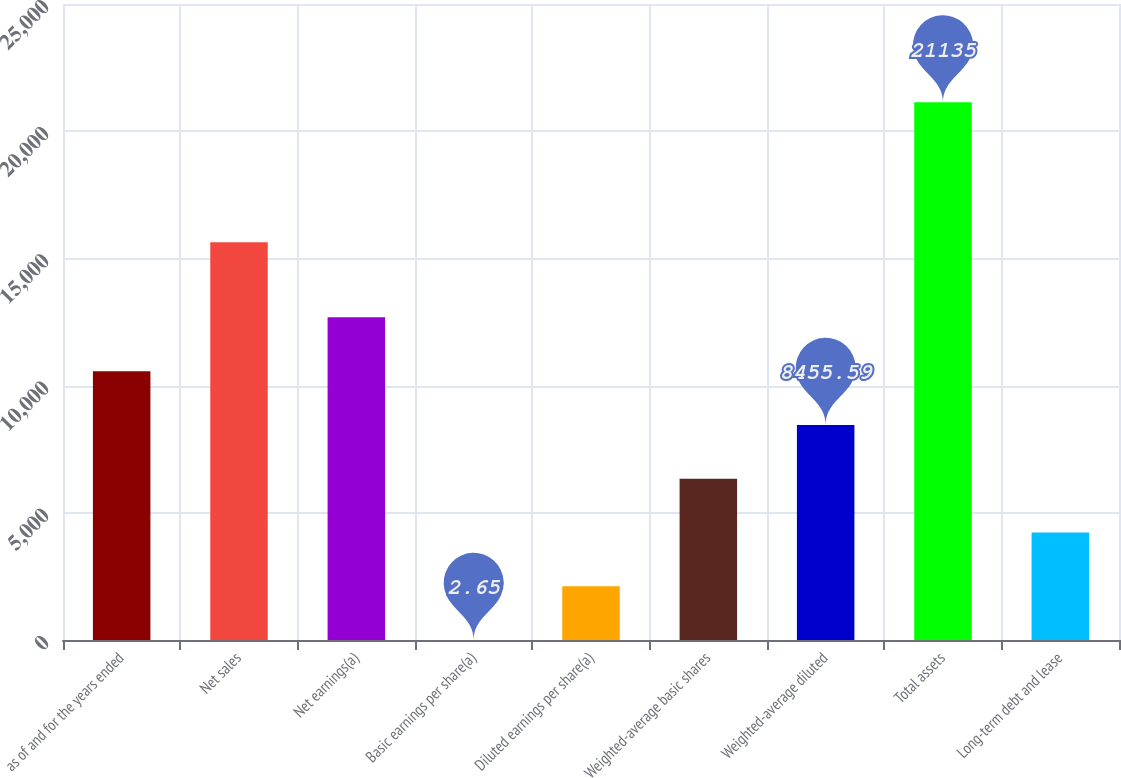Convert chart. <chart><loc_0><loc_0><loc_500><loc_500><bar_chart><fcel>as of and for the years ended<fcel>Net sales<fcel>Net earnings(a)<fcel>Basic earnings per share(a)<fcel>Diluted earnings per share(a)<fcel>Weighted-average basic shares<fcel>Weighted-average diluted<fcel>Total assets<fcel>Long-term debt and lease<nl><fcel>10568.8<fcel>15638<fcel>12682.1<fcel>2.65<fcel>2115.89<fcel>6342.35<fcel>8455.59<fcel>21135<fcel>4229.12<nl></chart> 